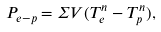Convert formula to latex. <formula><loc_0><loc_0><loc_500><loc_500>P _ { e - p } = \Sigma V ( T ^ { n } _ { e } - T ^ { n } _ { p } ) ,</formula> 